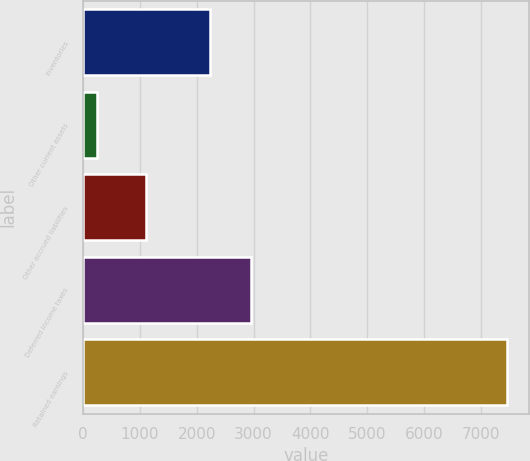<chart> <loc_0><loc_0><loc_500><loc_500><bar_chart><fcel>Inventories<fcel>Other current assets<fcel>Other accrued liabilities<fcel>Deferred income taxes<fcel>Retained earnings<nl><fcel>2241<fcel>250<fcel>1107<fcel>2962.5<fcel>7465<nl></chart> 